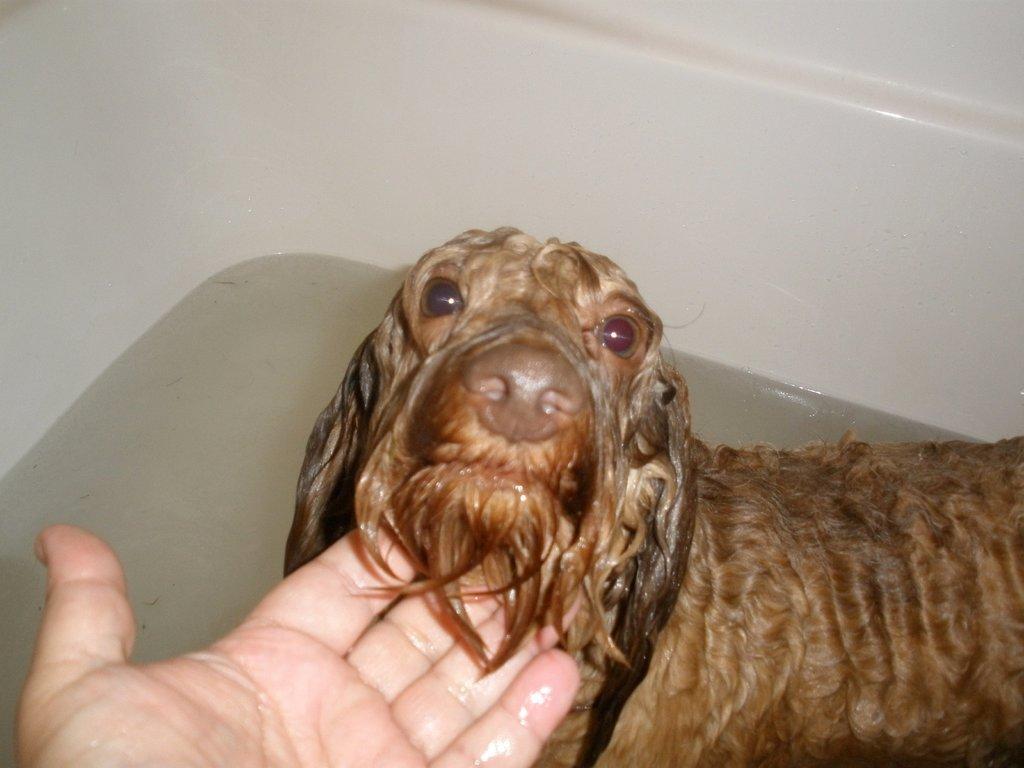Please provide a concise description of this image. In this picture we can see a puppy in a bathtub having a bath and liking someone's hand. 